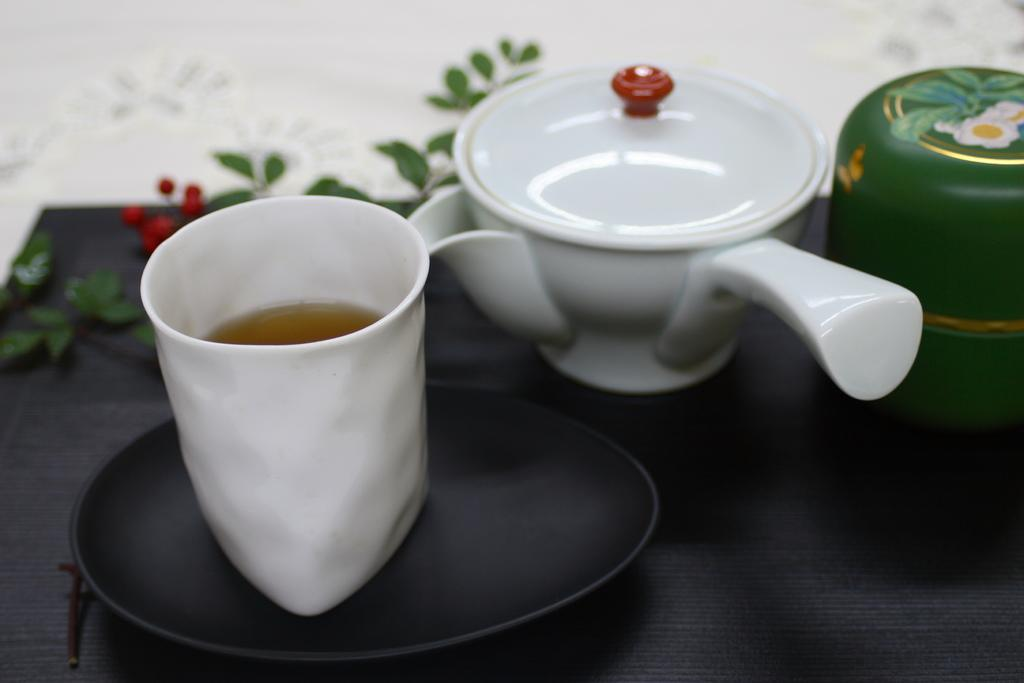What is on the table in the image? There is a kettle and a cup on the table. What might be used for heating water in the image? The kettle on the table might be used for heating water. What might be used for drinking in the image? The cup on the table might be used for drinking. What type of notebook is visible on the table in the image? There is no notebook present in the image; only a kettle and a cup are visible on the table. 